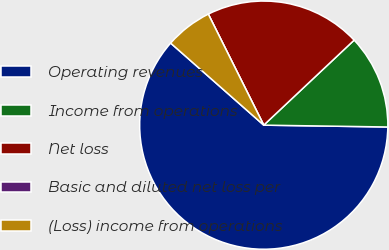Convert chart to OTSL. <chart><loc_0><loc_0><loc_500><loc_500><pie_chart><fcel>Operating revenues<fcel>Income from operations<fcel>Net loss<fcel>Basic and diluted net loss per<fcel>(Loss) income from operations<nl><fcel>61.26%<fcel>12.25%<fcel>20.36%<fcel>0.0%<fcel>6.13%<nl></chart> 